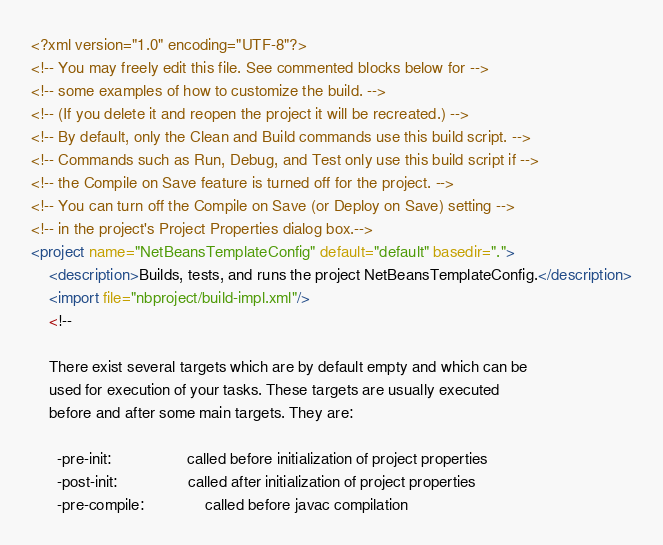Convert code to text. <code><loc_0><loc_0><loc_500><loc_500><_XML_><?xml version="1.0" encoding="UTF-8"?>
<!-- You may freely edit this file. See commented blocks below for -->
<!-- some examples of how to customize the build. -->
<!-- (If you delete it and reopen the project it will be recreated.) -->
<!-- By default, only the Clean and Build commands use this build script. -->
<!-- Commands such as Run, Debug, and Test only use this build script if -->
<!-- the Compile on Save feature is turned off for the project. -->
<!-- You can turn off the Compile on Save (or Deploy on Save) setting -->
<!-- in the project's Project Properties dialog box.-->
<project name="NetBeansTemplateConfig" default="default" basedir=".">
    <description>Builds, tests, and runs the project NetBeansTemplateConfig.</description>
    <import file="nbproject/build-impl.xml"/>
    <!--

    There exist several targets which are by default empty and which can be 
    used for execution of your tasks. These targets are usually executed 
    before and after some main targets. They are: 

      -pre-init:                 called before initialization of project properties
      -post-init:                called after initialization of project properties
      -pre-compile:              called before javac compilation</code> 